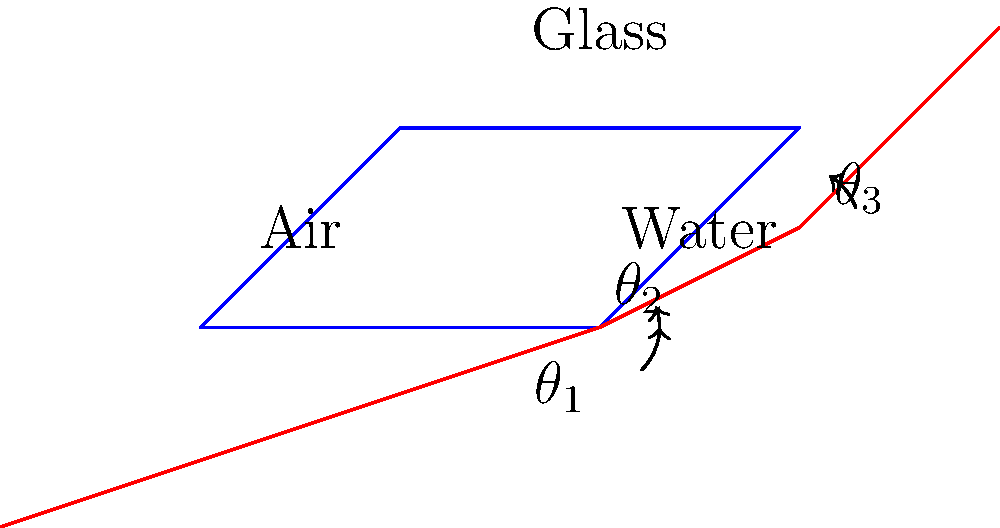A light ray passes through three different media: air, water, and glass, as shown in the diagram. Given that the refractive indices of air, water, and glass are 1.00, 1.33, and 1.50 respectively, and the angle of incidence in air is 45°, calculate the angle of refraction in the glass medium. To solve this problem, we'll use Snell's Law at each interface and apply it twice:

1) At the air-water interface:
   $$n_1 \sin(\theta_1) = n_2 \sin(\theta_2)$$
   $$1.00 \sin(45°) = 1.33 \sin(\theta_2)$$
   $$\sin(\theta_2) = \frac{1.00 \sin(45°)}{1.33} = 0.5303$$
   $$\theta_2 = \arcsin(0.5303) = 32.0°$$

2) At the water-glass interface:
   $$n_2 \sin(\theta_2) = n_3 \sin(\theta_3)$$
   $$1.33 \sin(32.0°) = 1.50 \sin(\theta_3)$$
   $$\sin(\theta_3) = \frac{1.33 \sin(32.0°)}{1.50} = 0.4702$$
   $$\theta_3 = \arcsin(0.4702) = 28.1°$$

Therefore, the angle of refraction in the glass medium is approximately 28.1°.
Answer: 28.1° 